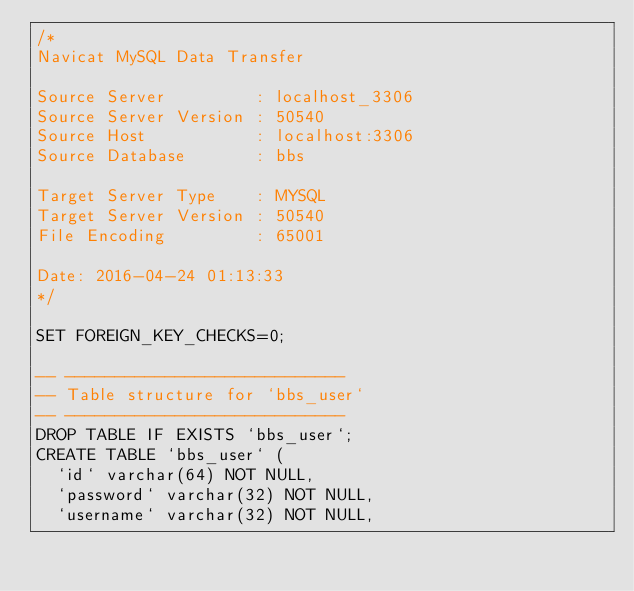Convert code to text. <code><loc_0><loc_0><loc_500><loc_500><_SQL_>/*
Navicat MySQL Data Transfer

Source Server         : localhost_3306
Source Server Version : 50540
Source Host           : localhost:3306
Source Database       : bbs

Target Server Type    : MYSQL
Target Server Version : 50540
File Encoding         : 65001

Date: 2016-04-24 01:13:33
*/

SET FOREIGN_KEY_CHECKS=0;

-- ----------------------------
-- Table structure for `bbs_user`
-- ----------------------------
DROP TABLE IF EXISTS `bbs_user`;
CREATE TABLE `bbs_user` (
  `id` varchar(64) NOT NULL,
  `password` varchar(32) NOT NULL,
  `username` varchar(32) NOT NULL,</code> 